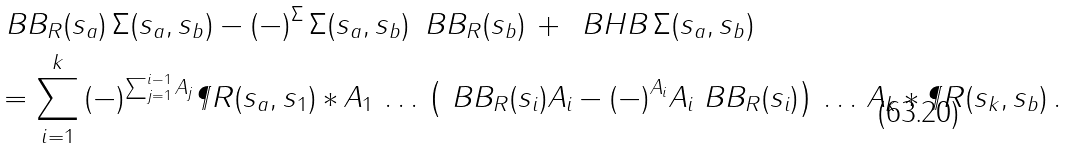Convert formula to latex. <formula><loc_0><loc_0><loc_500><loc_500>& \ B B _ { R } ( s _ { a } ) \, \Sigma ( s _ { a } , s _ { b } ) - ( - ) ^ { \Sigma } \, \Sigma ( s _ { a } , s _ { b } ) \, \ B B _ { R } ( s _ { b } ) \, + \, \ B H B \, \Sigma ( s _ { a } , s _ { b } ) \\ & = \sum _ { i = 1 } ^ { k } \, ( - ) ^ { \sum _ { j = 1 } ^ { i - 1 } A _ { j } } \P R ( s _ { a } , s _ { 1 } ) \ast A _ { 1 } \, \dots \, \left ( \ B B _ { R } ( s _ { i } ) A _ { i } - ( - ) ^ { A _ { i } } A _ { i } \ B B _ { R } ( s _ { i } ) \right ) \, \dots \, A _ { k } \ast \P R ( s _ { k } , s _ { b } ) \, .</formula> 